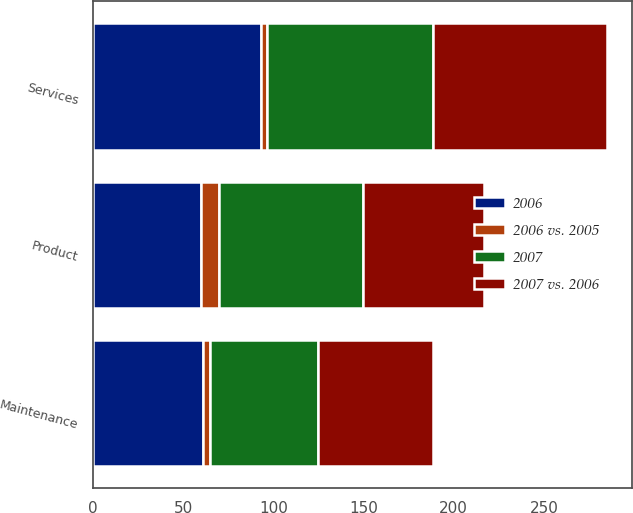Convert chart to OTSL. <chart><loc_0><loc_0><loc_500><loc_500><stacked_bar_chart><ecel><fcel>Product<fcel>Services<fcel>Maintenance<nl><fcel>2006<fcel>60.1<fcel>93.4<fcel>61.1<nl><fcel>2007 vs. 2006<fcel>66.8<fcel>96.5<fcel>63.8<nl><fcel>2007<fcel>79.7<fcel>91.9<fcel>59.8<nl><fcel>2006 vs. 2005<fcel>10<fcel>3<fcel>4<nl></chart> 